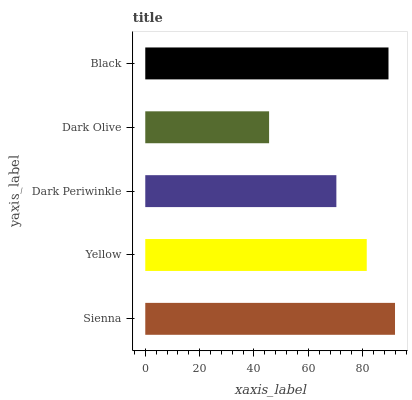Is Dark Olive the minimum?
Answer yes or no. Yes. Is Sienna the maximum?
Answer yes or no. Yes. Is Yellow the minimum?
Answer yes or no. No. Is Yellow the maximum?
Answer yes or no. No. Is Sienna greater than Yellow?
Answer yes or no. Yes. Is Yellow less than Sienna?
Answer yes or no. Yes. Is Yellow greater than Sienna?
Answer yes or no. No. Is Sienna less than Yellow?
Answer yes or no. No. Is Yellow the high median?
Answer yes or no. Yes. Is Yellow the low median?
Answer yes or no. Yes. Is Black the high median?
Answer yes or no. No. Is Sienna the low median?
Answer yes or no. No. 